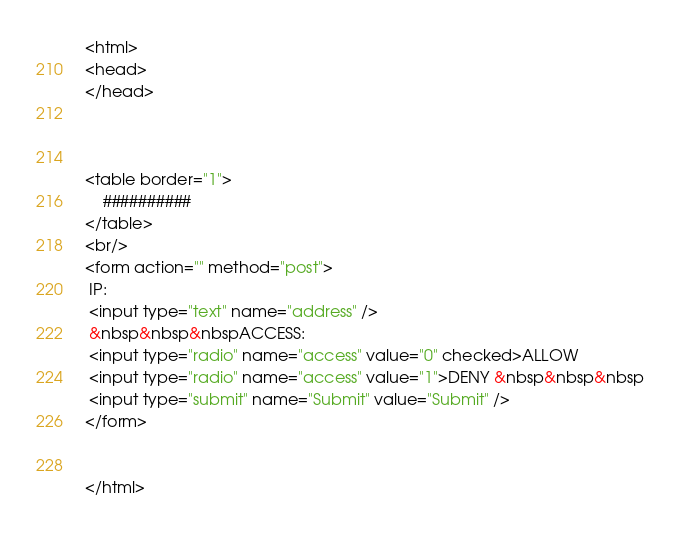<code> <loc_0><loc_0><loc_500><loc_500><_HTML_><html>
<head>
</head>



<table border="1">
    ##########
</table>
<br/>
<form action="" method="post">
 IP:
 <input type="text" name="address" />
 &nbsp&nbsp&nbspACCESS:
 <input type="radio" name="access" value="0" checked>ALLOW
 <input type="radio" name="access" value="1">DENY &nbsp&nbsp&nbsp
 <input type="submit" name="Submit" value="Submit" />
</form>


</html>


</code> 